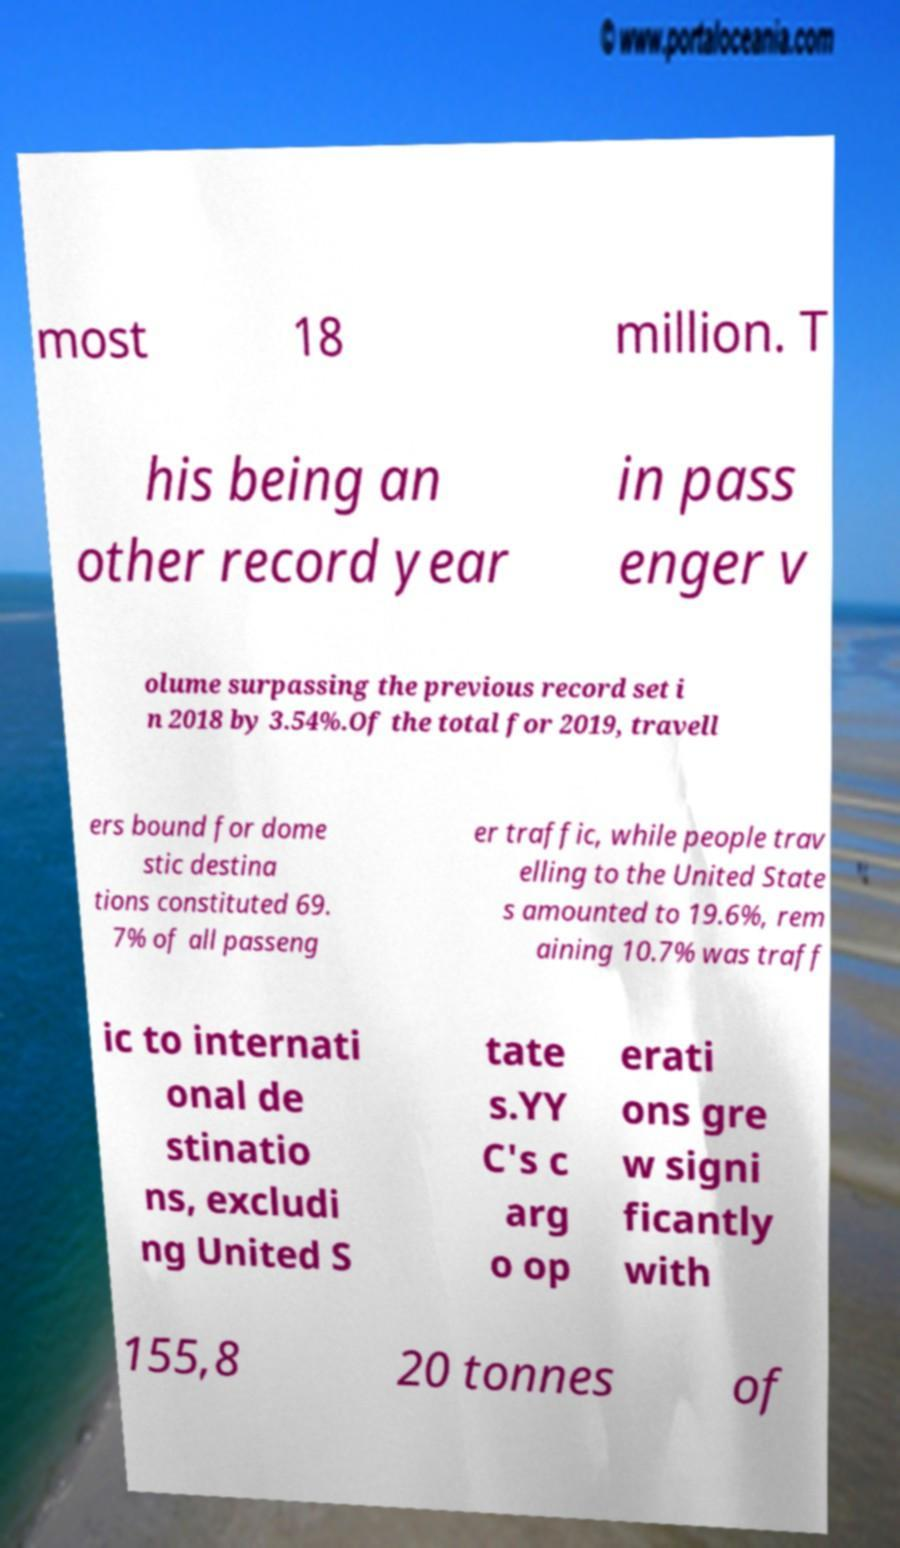Can you read and provide the text displayed in the image?This photo seems to have some interesting text. Can you extract and type it out for me? most 18 million. T his being an other record year in pass enger v olume surpassing the previous record set i n 2018 by 3.54%.Of the total for 2019, travell ers bound for dome stic destina tions constituted 69. 7% of all passeng er traffic, while people trav elling to the United State s amounted to 19.6%, rem aining 10.7% was traff ic to internati onal de stinatio ns, excludi ng United S tate s.YY C's c arg o op erati ons gre w signi ficantly with 155,8 20 tonnes of 